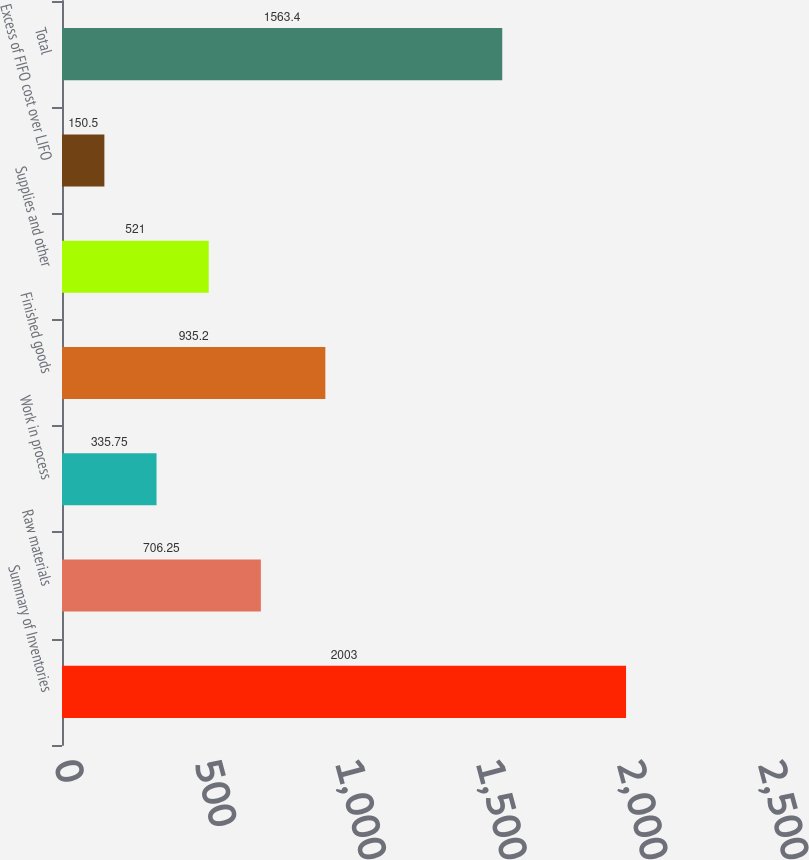Convert chart to OTSL. <chart><loc_0><loc_0><loc_500><loc_500><bar_chart><fcel>Summary of Inventories<fcel>Raw materials<fcel>Work in process<fcel>Finished goods<fcel>Supplies and other<fcel>Excess of FIFO cost over LIFO<fcel>Total<nl><fcel>2003<fcel>706.25<fcel>335.75<fcel>935.2<fcel>521<fcel>150.5<fcel>1563.4<nl></chart> 